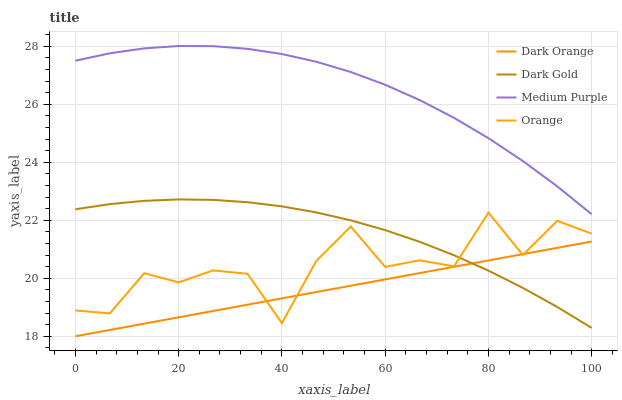Does Dark Orange have the minimum area under the curve?
Answer yes or no. Yes. Does Medium Purple have the maximum area under the curve?
Answer yes or no. Yes. Does Orange have the minimum area under the curve?
Answer yes or no. No. Does Orange have the maximum area under the curve?
Answer yes or no. No. Is Dark Orange the smoothest?
Answer yes or no. Yes. Is Orange the roughest?
Answer yes or no. Yes. Is Orange the smoothest?
Answer yes or no. No. Is Dark Orange the roughest?
Answer yes or no. No. Does Dark Orange have the lowest value?
Answer yes or no. Yes. Does Orange have the lowest value?
Answer yes or no. No. Does Medium Purple have the highest value?
Answer yes or no. Yes. Does Orange have the highest value?
Answer yes or no. No. Is Dark Gold less than Medium Purple?
Answer yes or no. Yes. Is Medium Purple greater than Dark Orange?
Answer yes or no. Yes. Does Dark Gold intersect Orange?
Answer yes or no. Yes. Is Dark Gold less than Orange?
Answer yes or no. No. Is Dark Gold greater than Orange?
Answer yes or no. No. Does Dark Gold intersect Medium Purple?
Answer yes or no. No. 